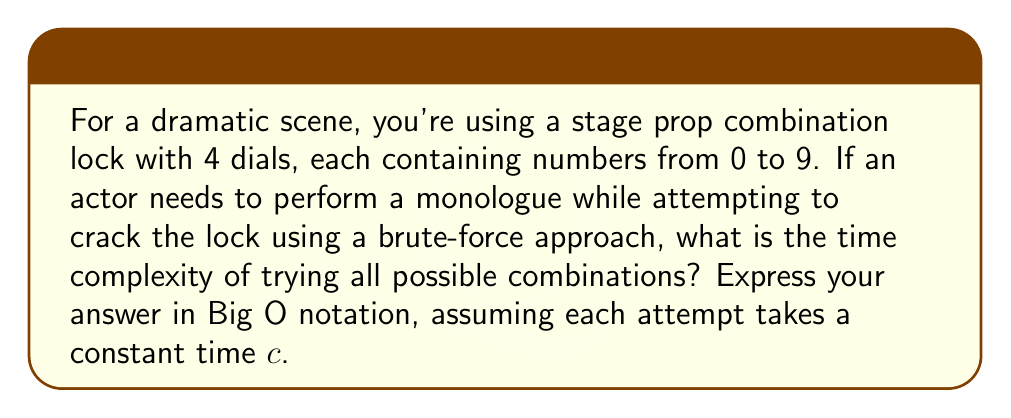Give your solution to this math problem. Let's break this down step-by-step:

1) First, we need to determine the total number of possible combinations:
   - Each dial has 10 options (0 to 9)
   - There are 4 dials
   - Total combinations = $10 * 10 * 10 * 10 = 10^4 = 10000$

2) In a brute-force attack, we need to try every possible combination in the worst case.

3) If each attempt takes a constant time $c$, then the total time $T$ would be:
   $T = c * 10000 = c * 10^4$

4) In Big O notation, we ignore constant factors. So, we can drop the $c$.

5) The time complexity is therefore $O(10^4)$. However, in Big O notation, we typically express this in terms of a variable.

6) Let $n$ represent the number of dials. In this case, $n = 4$.

7) The number of combinations can be expressed as $10^n$.

8) Therefore, the general time complexity for $n$ dials is $O(10^n)$.

This means that the time to crack the lock grows exponentially with the number of dials, making it increasingly difficult for longer combinations.
Answer: $O(10^n)$, where $n$ is the number of dials 